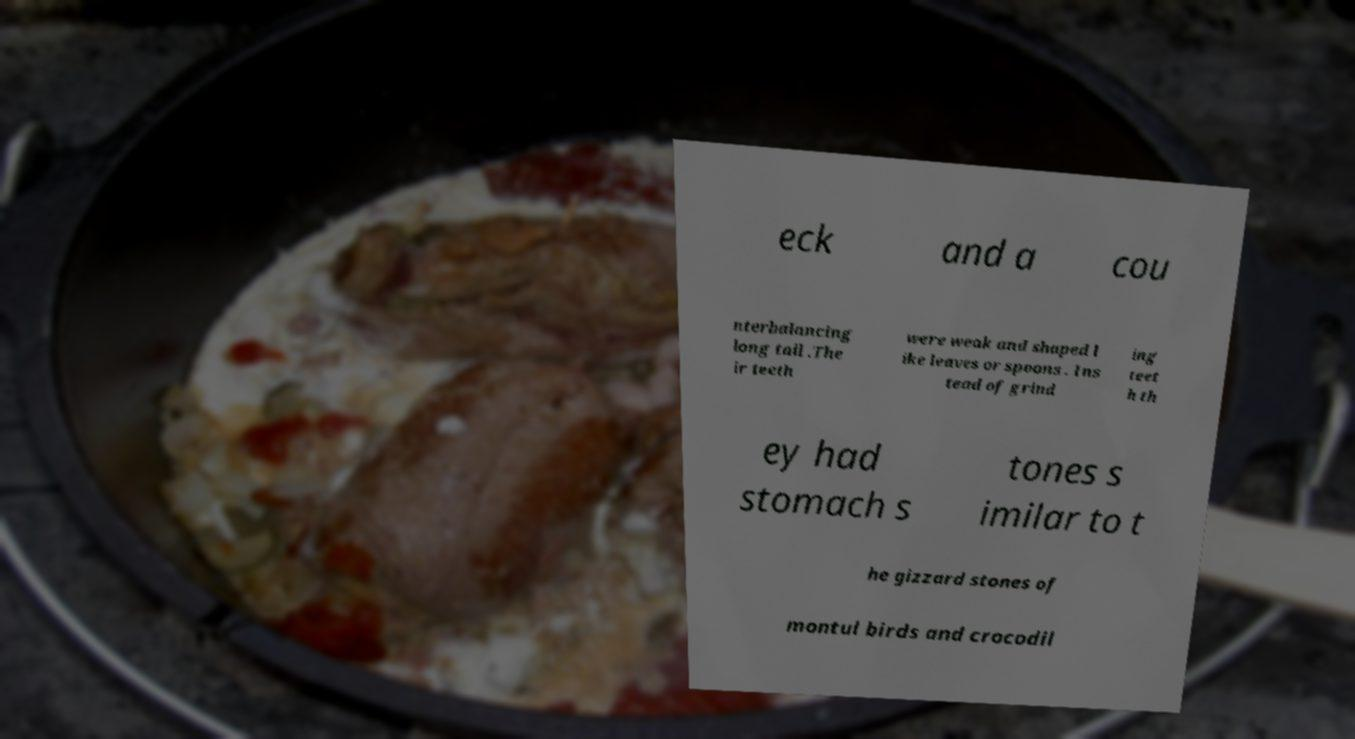Please identify and transcribe the text found in this image. eck and a cou nterbalancing long tail .The ir teeth were weak and shaped l ike leaves or spoons . Ins tead of grind ing teet h th ey had stomach s tones s imilar to t he gizzard stones of montul birds and crocodil 